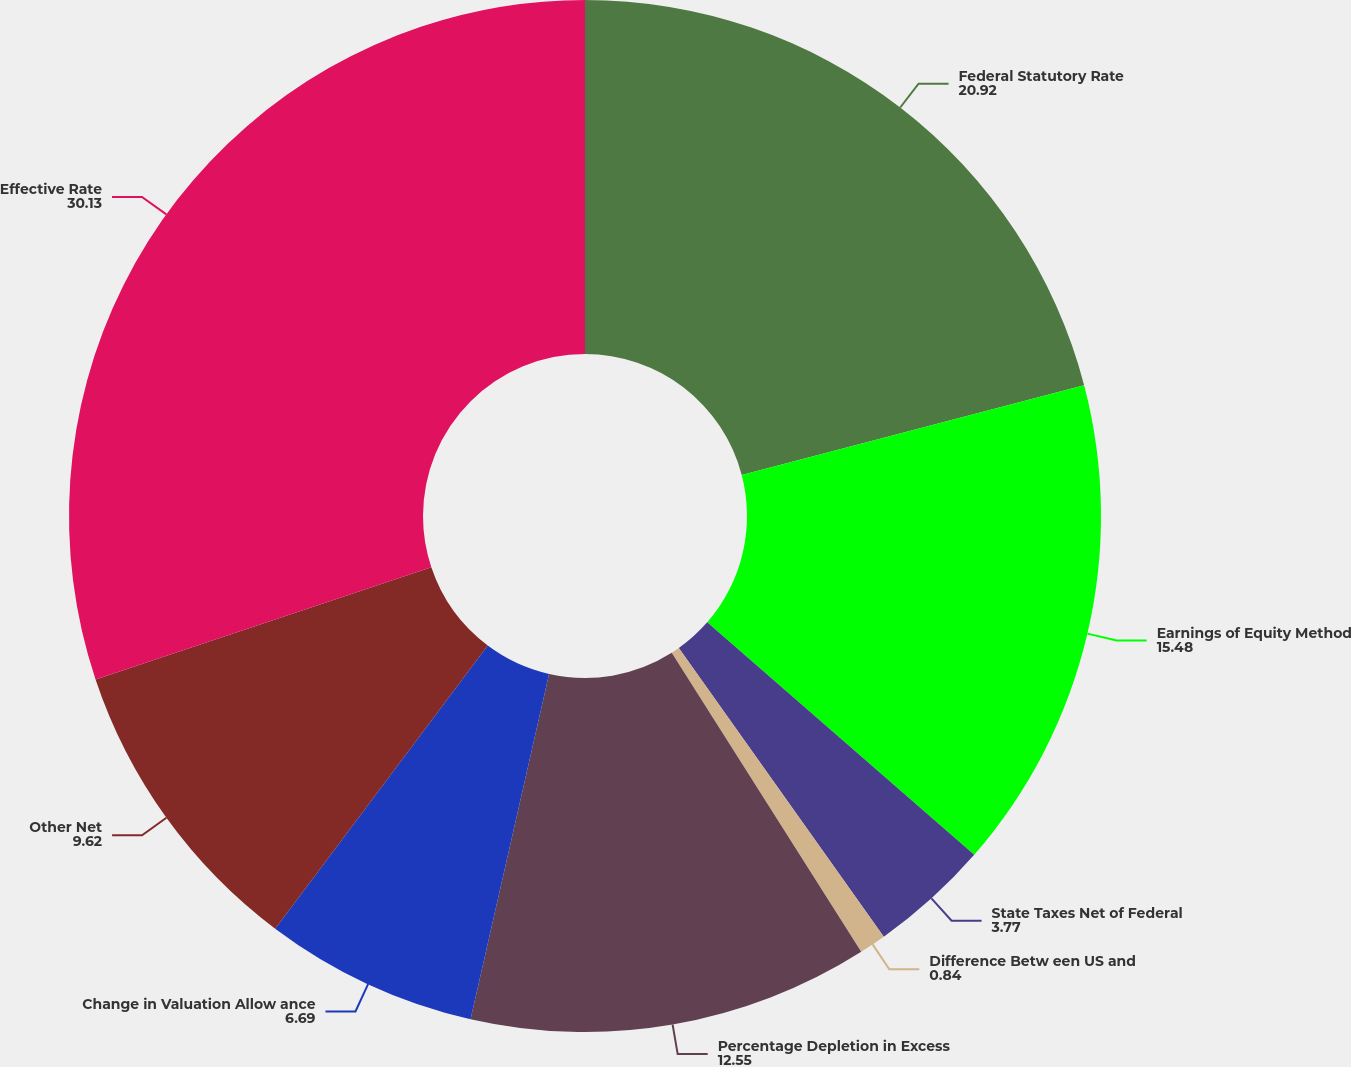Convert chart. <chart><loc_0><loc_0><loc_500><loc_500><pie_chart><fcel>Federal Statutory Rate<fcel>Earnings of Equity Method<fcel>State Taxes Net of Federal<fcel>Difference Betw een US and<fcel>Percentage Depletion in Excess<fcel>Change in Valuation Allow ance<fcel>Other Net<fcel>Effective Rate<nl><fcel>20.92%<fcel>15.48%<fcel>3.77%<fcel>0.84%<fcel>12.55%<fcel>6.69%<fcel>9.62%<fcel>30.13%<nl></chart> 